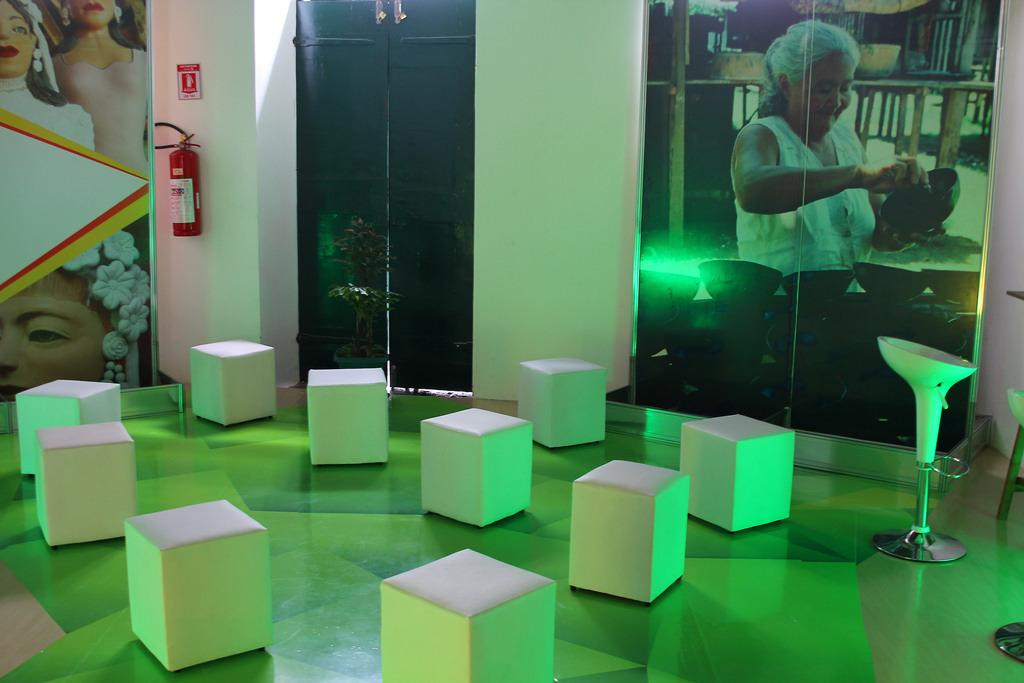What can be seen hanging on the wall in the image? There are photo frames on the wall. What safety device is visible in the image? There is a fire extinguisher in the image. What type of objects are present in the image that might be used for storage? There are boxes in the image. What piece of furniture is in the image that can be used for sitting or standing? There is a stool in the image. What type of door is present in the image? There is a metal door in the image. How many pizzas are stacked on top of the stool in the image? There are no pizzas present in the image; it features photo frames, a fire extinguisher, boxes, a stool, and a metal door. What type of bikes are leaning against the metal door in the image? There are no bikes present in the image; it features photo frames, a fire extinguisher, boxes, a stool, and a metal door. 